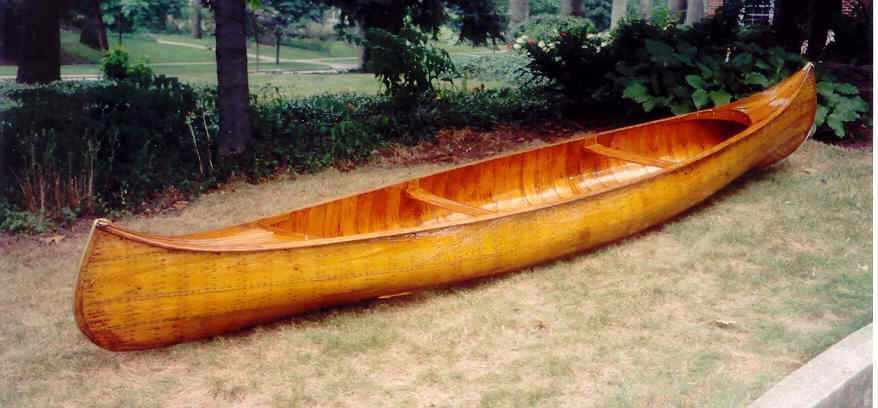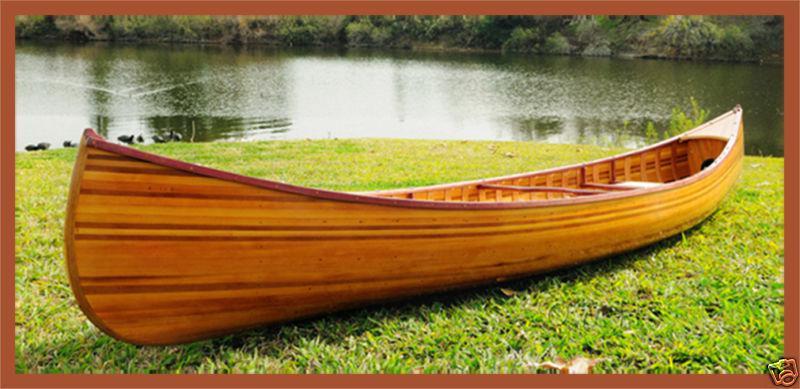The first image is the image on the left, the second image is the image on the right. Given the left and right images, does the statement "An image shows exactly one canoe sitting in the water." hold true? Answer yes or no. No. The first image is the image on the left, the second image is the image on the right. Analyze the images presented: Is the assertion "The left image shows one or more people inside a brown canoe that has a green top visible on it" valid? Answer yes or no. No. 